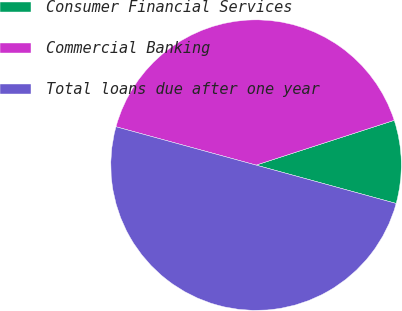Convert chart to OTSL. <chart><loc_0><loc_0><loc_500><loc_500><pie_chart><fcel>Consumer Financial Services<fcel>Commercial Banking<fcel>Total loans due after one year<nl><fcel>9.24%<fcel>40.76%<fcel>50.0%<nl></chart> 